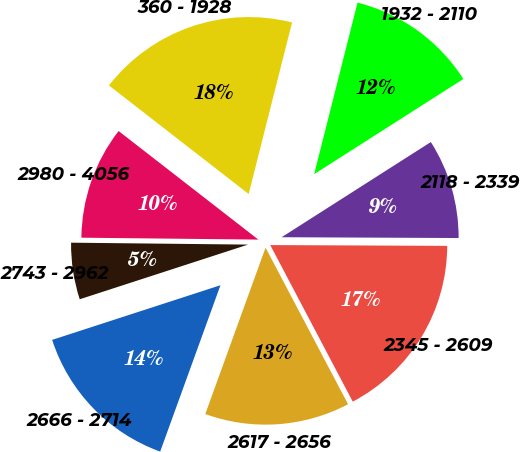<chart> <loc_0><loc_0><loc_500><loc_500><pie_chart><fcel>360 - 1928<fcel>1932 - 2110<fcel>2118 - 2339<fcel>2345 - 2609<fcel>2617 - 2656<fcel>2666 - 2714<fcel>2743 - 2962<fcel>2980 - 4056<nl><fcel>18.43%<fcel>12.02%<fcel>9.11%<fcel>17.21%<fcel>13.25%<fcel>14.47%<fcel>5.17%<fcel>10.34%<nl></chart> 